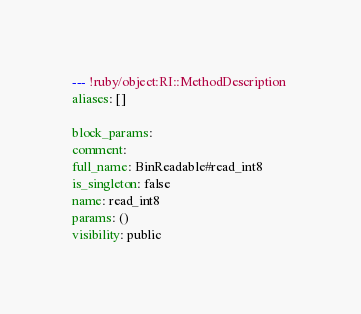Convert code to text. <code><loc_0><loc_0><loc_500><loc_500><_YAML_>--- !ruby/object:RI::MethodDescription 
aliases: []

block_params: 
comment: 
full_name: BinReadable#read_int8
is_singleton: false
name: read_int8
params: ()
visibility: public
</code> 